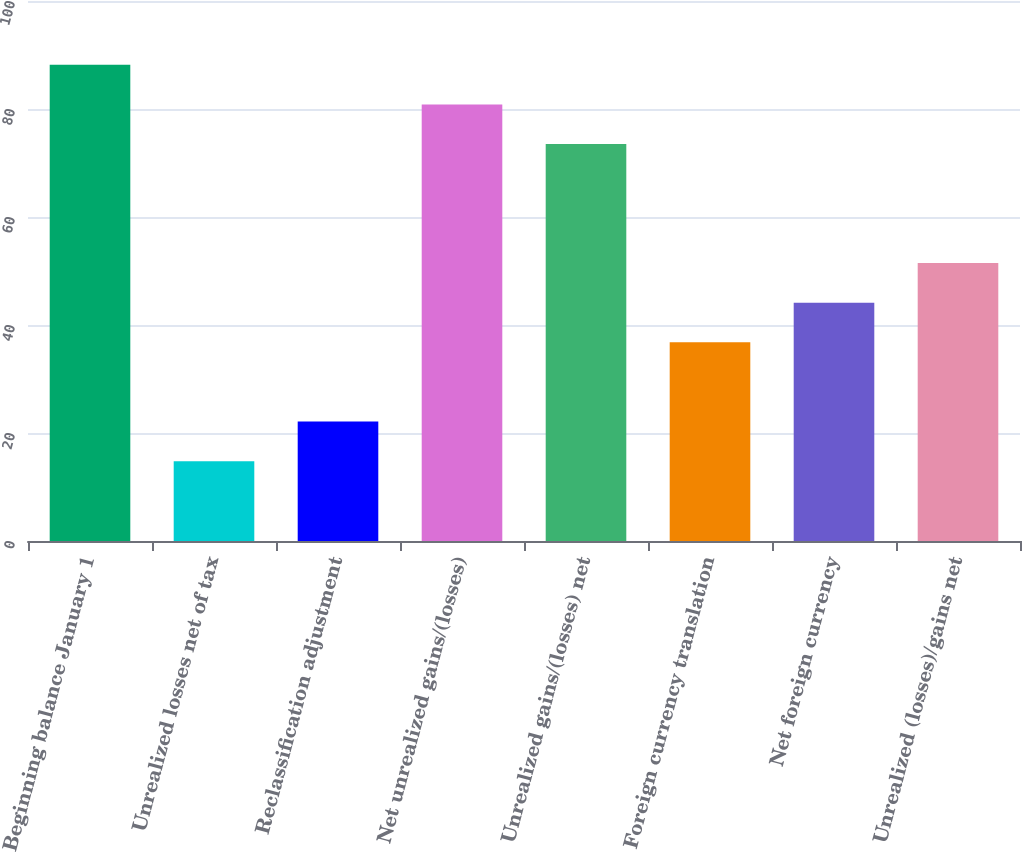Convert chart to OTSL. <chart><loc_0><loc_0><loc_500><loc_500><bar_chart><fcel>Beginning balance January 1<fcel>Unrealized losses net of tax<fcel>Reclassification adjustment<fcel>Net unrealized gains/(losses)<fcel>Unrealized gains/(losses) net<fcel>Foreign currency translation<fcel>Net foreign currency<fcel>Unrealized (losses)/gains net<nl><fcel>88.18<fcel>14.78<fcel>22.12<fcel>80.84<fcel>73.5<fcel>36.8<fcel>44.14<fcel>51.48<nl></chart> 